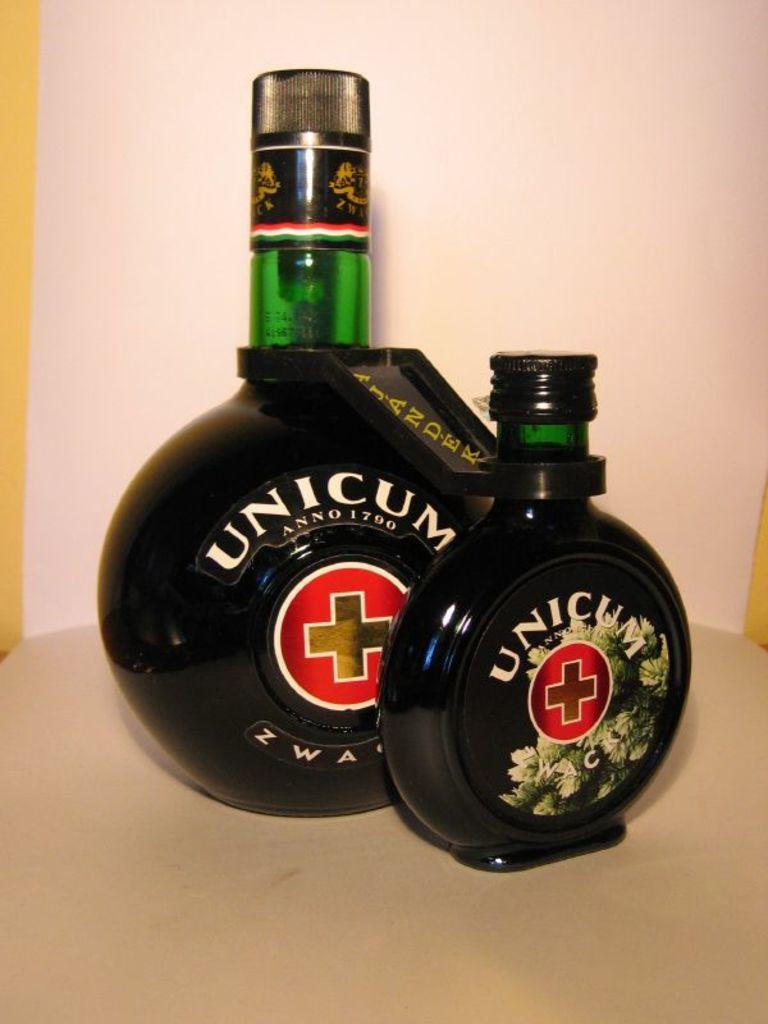Provide a one-sentence caption for the provided image. A large bottle and a small bottle of Unicum alcohol. 